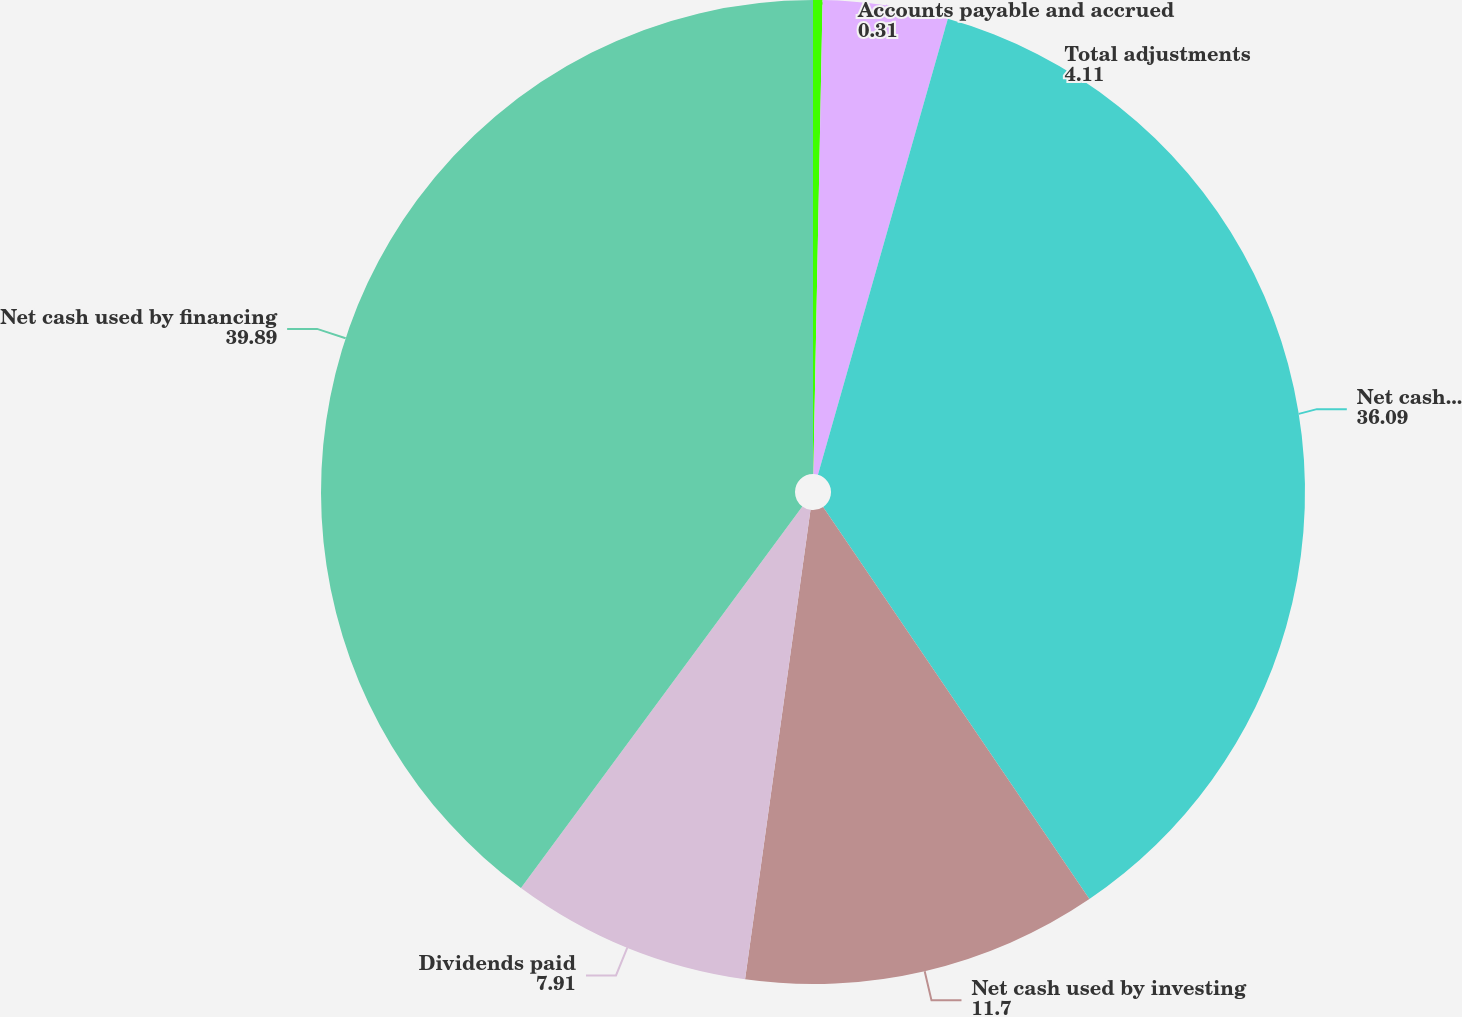Convert chart. <chart><loc_0><loc_0><loc_500><loc_500><pie_chart><fcel>Accounts payable and accrued<fcel>Total adjustments<fcel>Net cash provided by operating<fcel>Net cash used by investing<fcel>Dividends paid<fcel>Net cash used by financing<nl><fcel>0.31%<fcel>4.11%<fcel>36.09%<fcel>11.7%<fcel>7.91%<fcel>39.89%<nl></chart> 